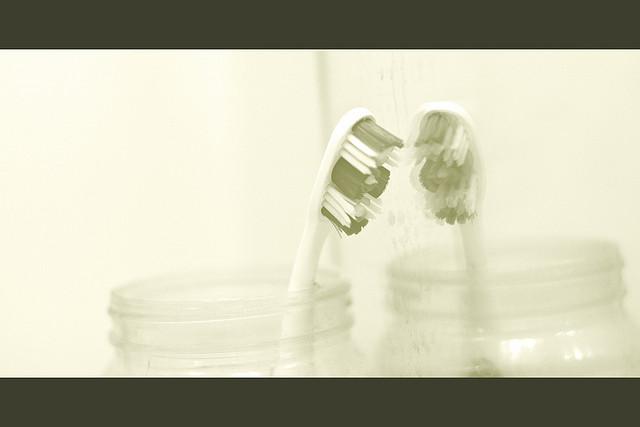What is being but on the toothbrush?
Give a very brief answer. Nothing. Is there a mirror?
Give a very brief answer. Yes. What brand of toothpaste is this?
Give a very brief answer. Colgate. What is the purpose of the white indents on the handle of the blue toothbrush?
Quick response, please. Grip. What object is this?
Be succinct. Toothbrush. Is the toothbrush in a cup?
Write a very short answer. Yes. 